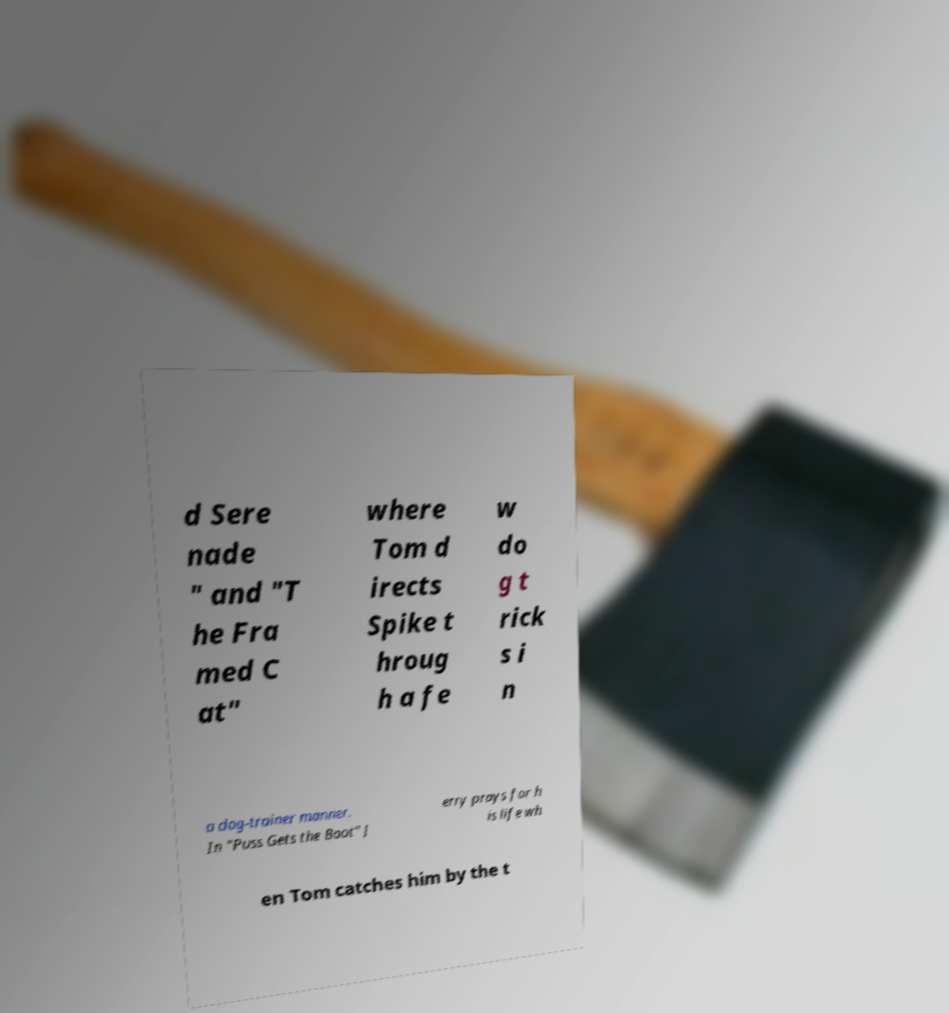Could you extract and type out the text from this image? d Sere nade " and "T he Fra med C at" where Tom d irects Spike t hroug h a fe w do g t rick s i n a dog-trainer manner. In "Puss Gets the Boot" J erry prays for h is life wh en Tom catches him by the t 